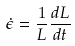<formula> <loc_0><loc_0><loc_500><loc_500>\dot { \epsilon } = \frac { 1 } { L } \frac { d L } { d t }</formula> 